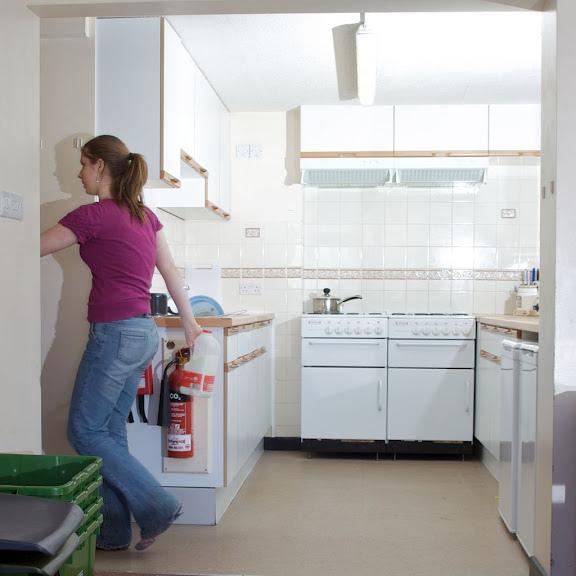Did she just cook something?
Answer briefly. No. Is this an eat-in kitchen?
Keep it brief. No. What is on top of the stove?
Answer briefly. Pot. How many cabinet doors are open?
Concise answer only. 0. Is the woman wearing formal clothes?
Give a very brief answer. No. 